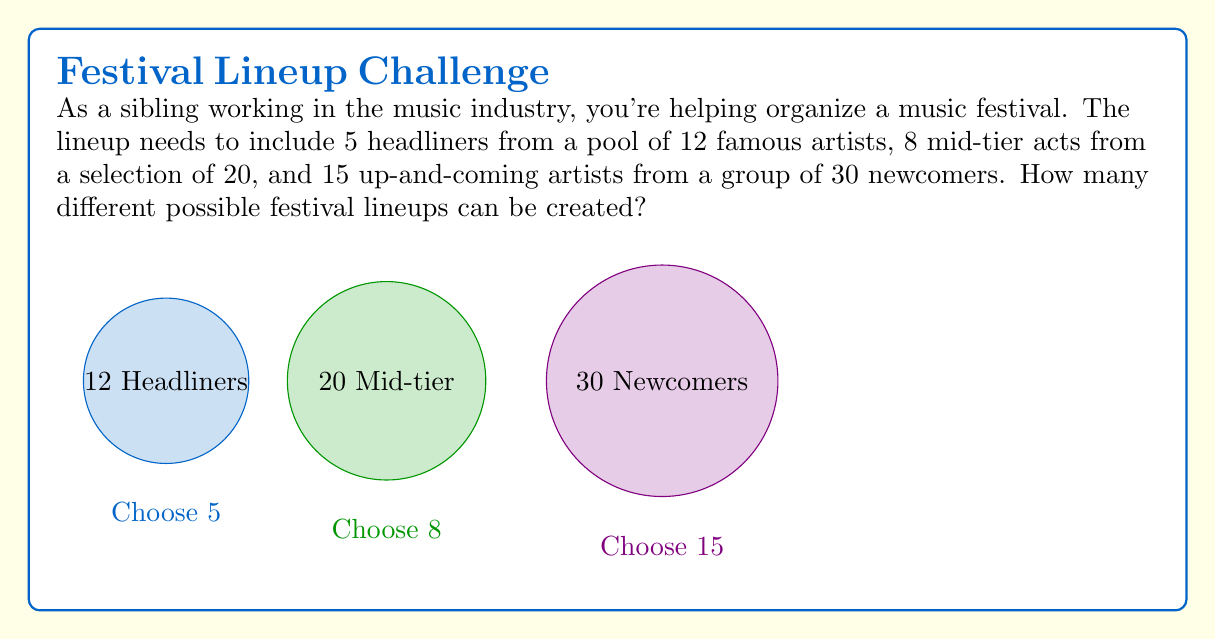Teach me how to tackle this problem. Let's break this down step-by-step:

1) For the headliners:
   We need to choose 5 out of 12 artists. This is a combination problem.
   $$\binom{12}{5} = \frac{12!}{5!(12-5)!} = \frac{12!}{5!7!} = 792$$

2) For the mid-tier acts:
   We need to choose 8 out of 20 artists.
   $$\binom{20}{8} = \frac{20!}{8!(20-8)!} = \frac{20!}{8!12!} = 125,970$$

3) For the up-and-coming artists:
   We need to choose 15 out of 30 artists.
   $$\binom{30}{15} = \frac{30!}{15!(30-15)!} = \frac{30!}{15!15!} = 155,117,520$$

4) By the Multiplication Principle, the total number of possible lineups is the product of these three combinations:

   $$792 \times 125,970 \times 155,117,520 = 15,511,572,830,832,000$$

This large number reflects the vast number of possibilities when creating a festival lineup, which explains why curating the perfect lineup can be such a challenging task in the music industry.
Answer: $15,511,572,830,832,000$ 